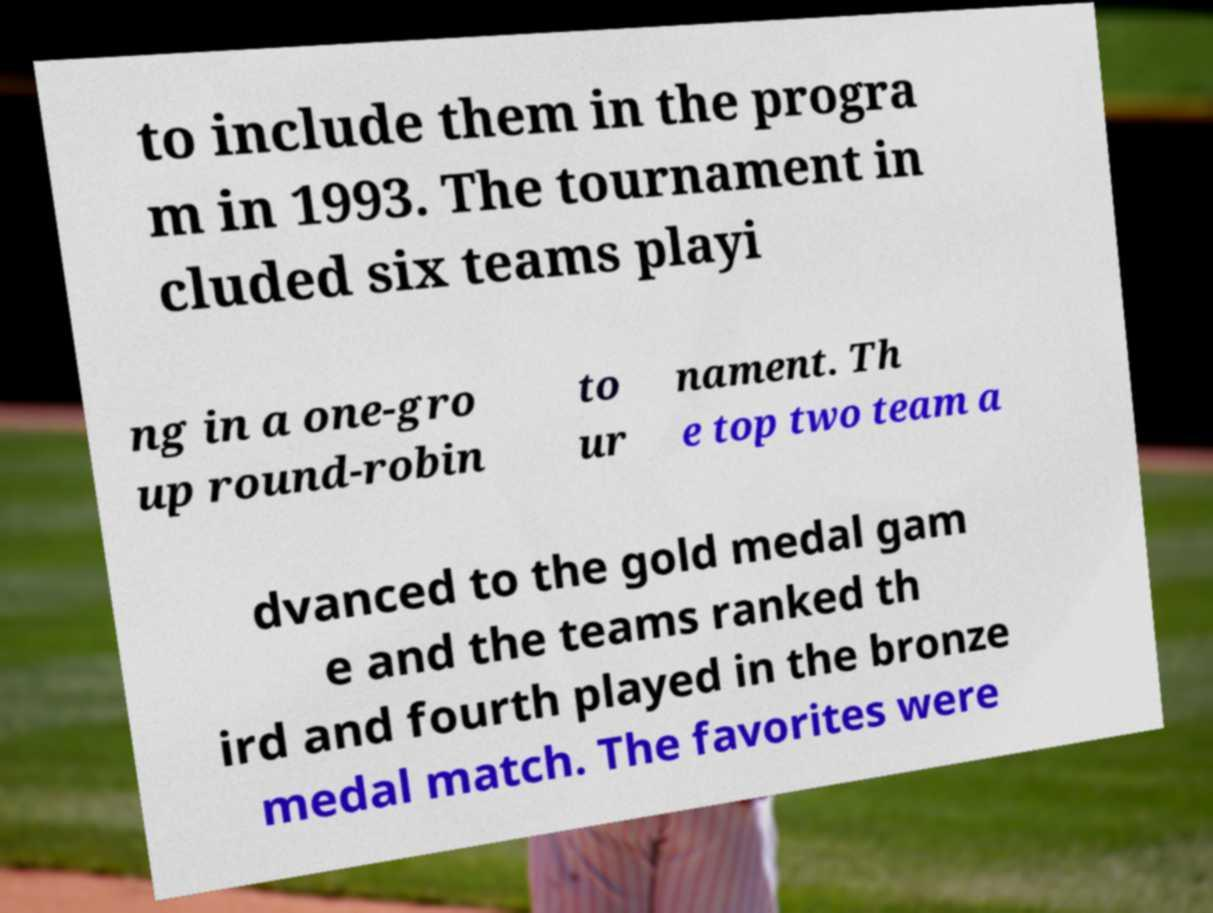I need the written content from this picture converted into text. Can you do that? to include them in the progra m in 1993. The tournament in cluded six teams playi ng in a one-gro up round-robin to ur nament. Th e top two team a dvanced to the gold medal gam e and the teams ranked th ird and fourth played in the bronze medal match. The favorites were 